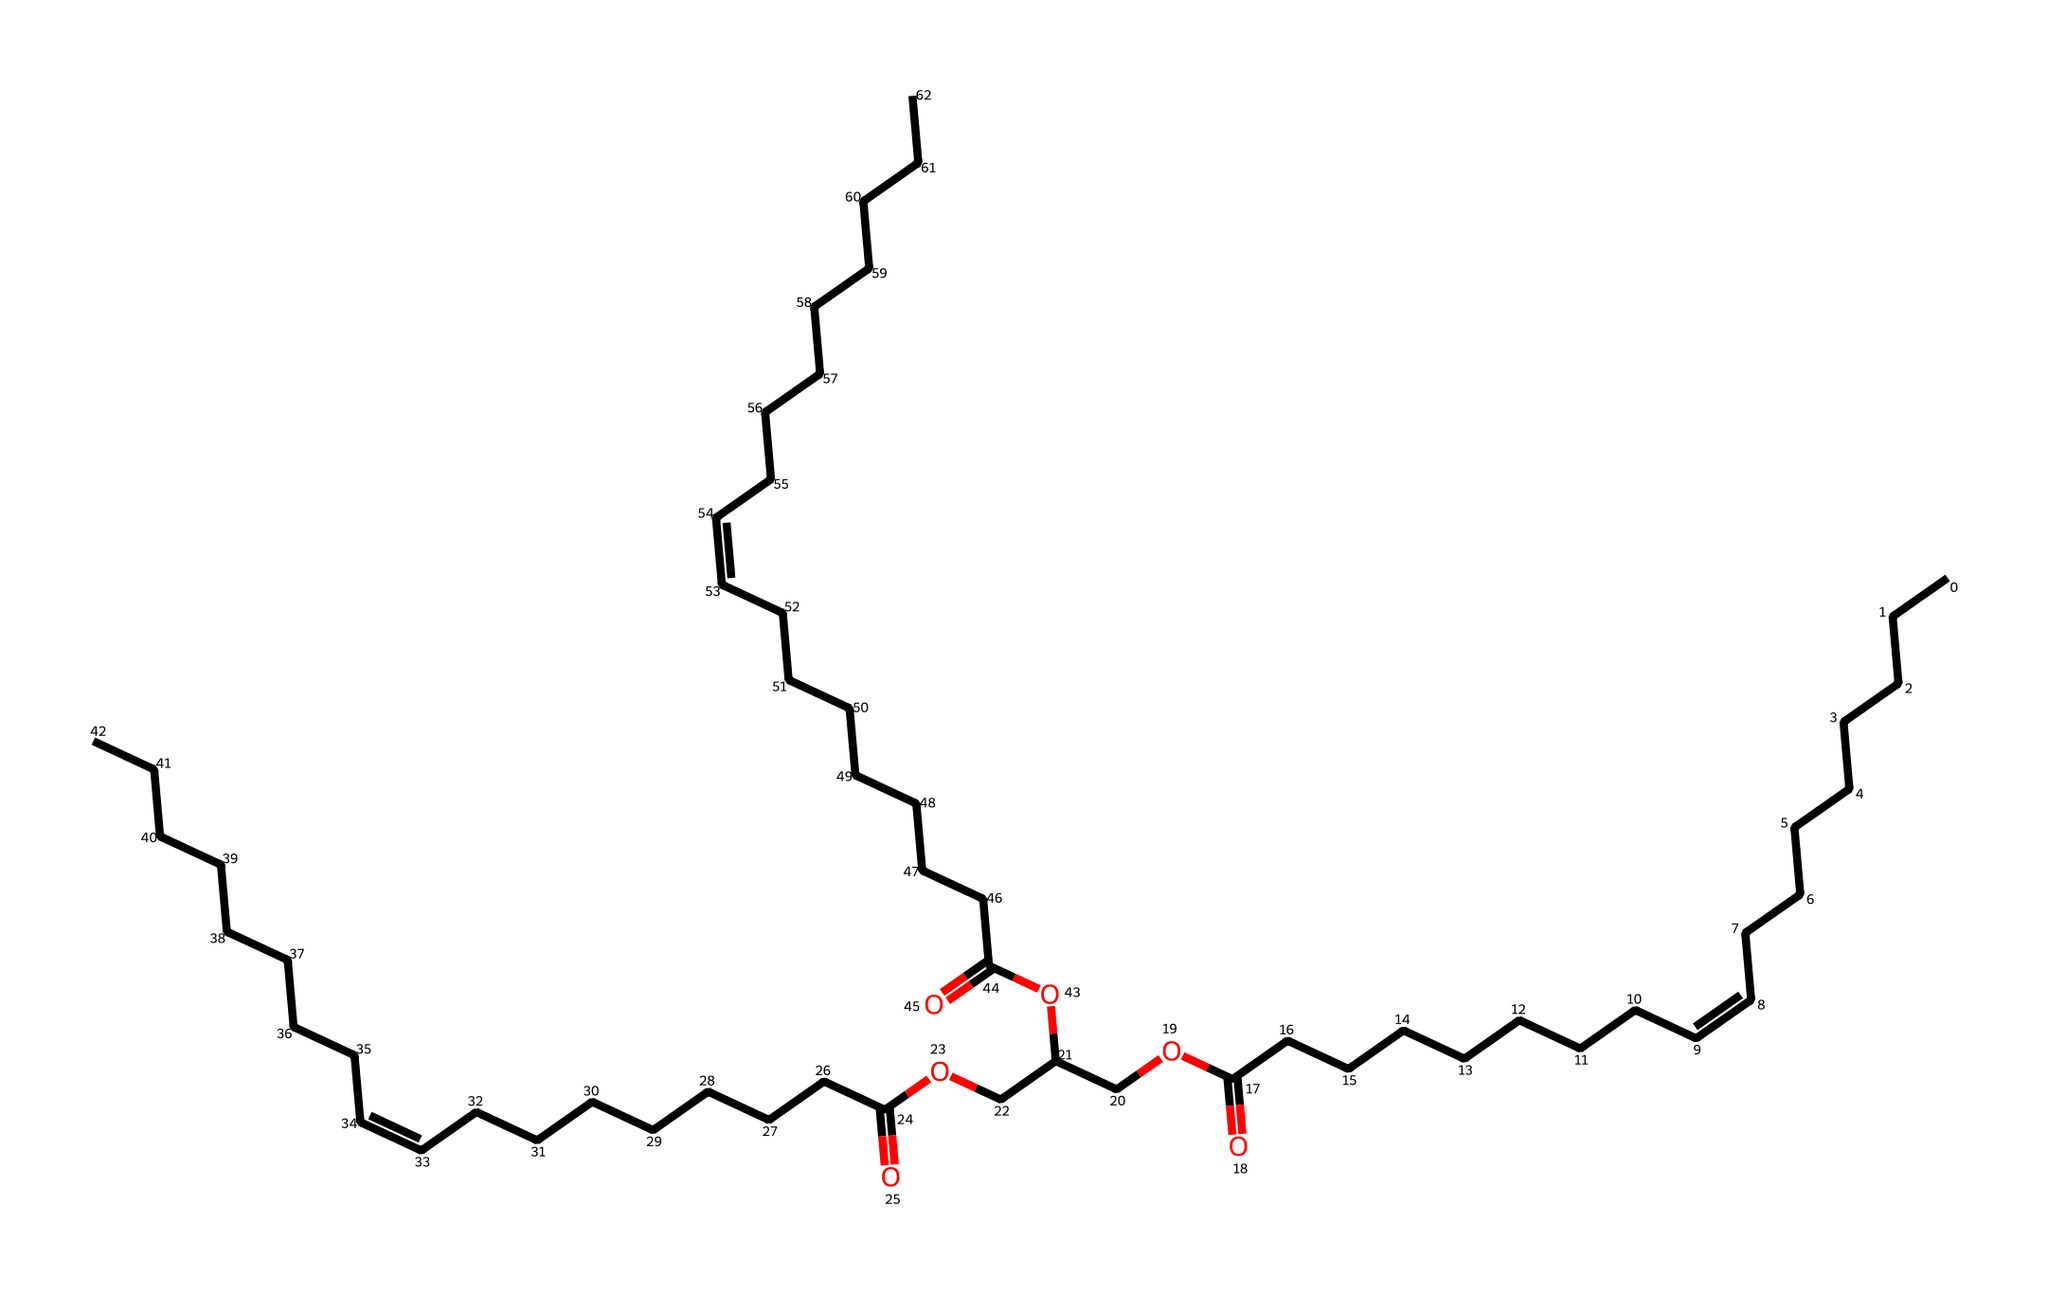What is the functional group present in this chemical structure? This chemical contains a carboxylic acid functional group (-COOH) and an ester functional group (-COOR) suggested by the -O linkage between carbon chains and the carbonyl (C=O) portion.
Answer: carboxylic acid, ester How many carbon atoms are in the entire structure? By counting the C symbols in the SMILES and recognizing each corresponds to a carbon atom, there are a total of 32 carbon atoms in the structure.
Answer: 32 What type of lipid is represented by this chemical structure? The structure is indicative of a triglyceride, which comprises three esterified fatty acids. The presence of multiple ester linkages signifies its classification as a lipid.
Answer: triglyceride What characteristic indicates that this compound is an ester? The presence of an alkoxy group (-O-R) bonded to a carbonyl group (C=O) is a defining characteristic of esters, which can be seen in the branching of the structure.
Answer: alkoxy group How many double bonds are present in this chemical structure? By analyzing the structure, it can be determined that there are 3 double bonds (indicated by "/C=C\") within the carbon framework.
Answer: 3 What role do esters play in olive oil's properties? Esters contribute to the flavor and aroma of olive oil, providing its characteristic taste and stability in cooking and food preservation, which is essential in Mediterranean cuisine.
Answer: flavor and aroma 